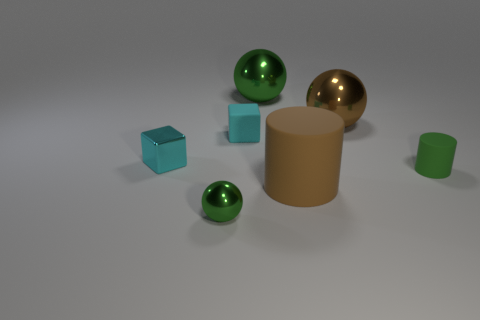Are there any other things that have the same shape as the green matte thing?
Your answer should be compact. Yes. There is a cyan rubber object; does it have the same shape as the small object to the right of the rubber cube?
Your answer should be compact. No. What is the brown cylinder made of?
Ensure brevity in your answer.  Rubber. What size is the other object that is the same shape as the cyan shiny object?
Keep it short and to the point. Small. How many other objects are the same material as the large green object?
Offer a very short reply. 3. Do the brown cylinder and the tiny thing that is on the right side of the big brown shiny sphere have the same material?
Your response must be concise. Yes. Is the number of big balls in front of the large cylinder less than the number of metal things that are to the right of the rubber cube?
Give a very brief answer. Yes. What is the color of the tiny shiny thing behind the small green cylinder?
Your answer should be compact. Cyan. How many other objects are the same color as the metal cube?
Your response must be concise. 1. Is the size of the brown object that is behind the cyan metallic cube the same as the small green rubber cylinder?
Ensure brevity in your answer.  No. 